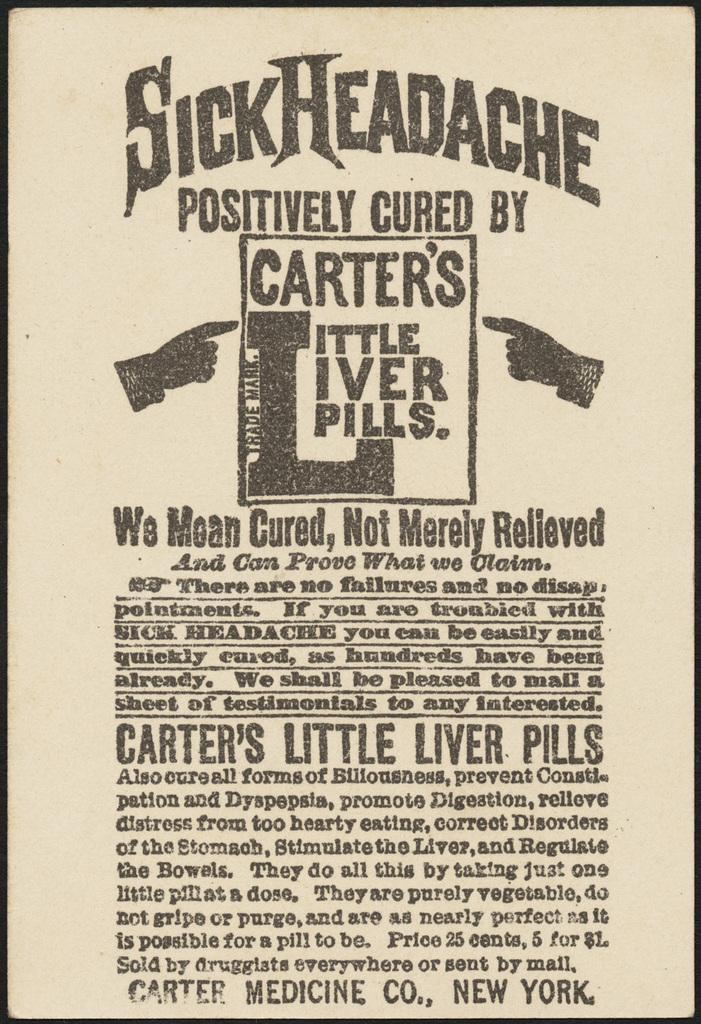Please provide a concise description of this image. In this image there are many English alphabets written in the paper. 